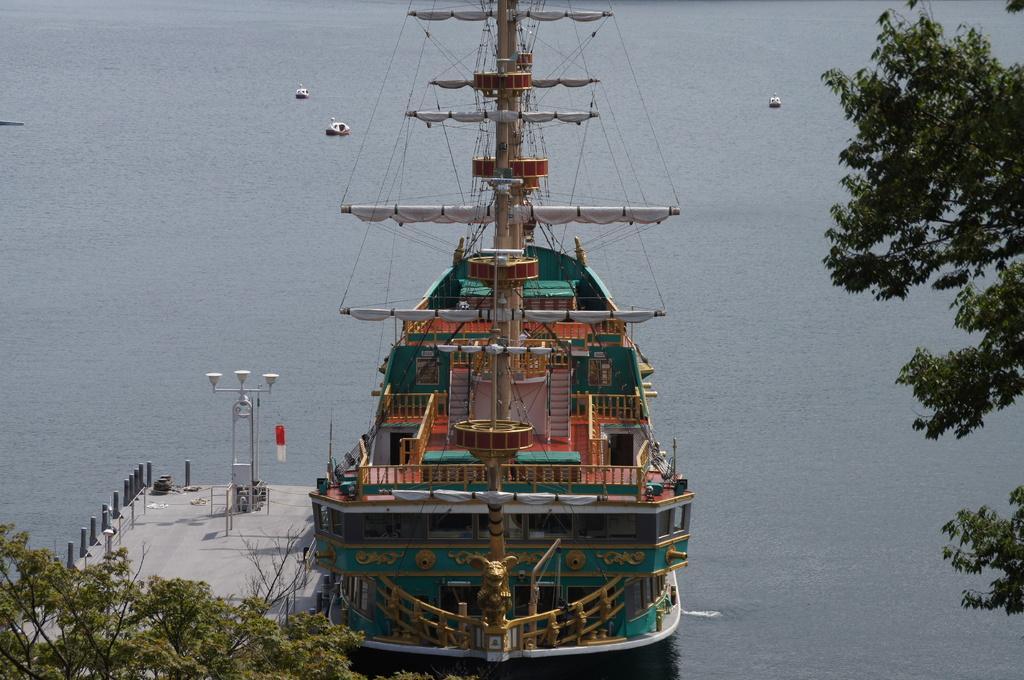How would you summarize this image in a sentence or two? In this image I can see water and on it I can see a ship. On the left side of this image I can see a platform and on it I can see number of poles and three lights. I can also see few trees in the front and in the background I can see three white color things on the water. 